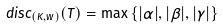Convert formula to latex. <formula><loc_0><loc_0><loc_500><loc_500>d i s c _ { ( K , w ) } ( T ) = \max \left \{ | \alpha | , | \beta | , | \gamma | \right \}</formula> 